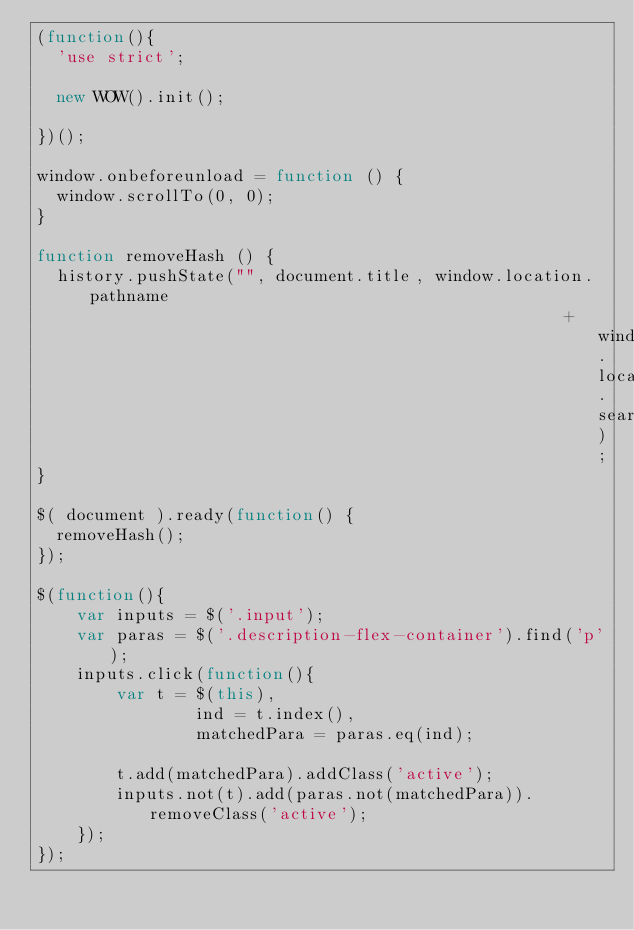<code> <loc_0><loc_0><loc_500><loc_500><_JavaScript_>(function(){
  'use strict';

  new WOW().init();
  
})();

window.onbeforeunload = function () {
  window.scrollTo(0, 0);
}

function removeHash () { 
  history.pushState("", document.title, window.location.pathname
                                                     + window.location.search);
}

$( document ).ready(function() {
  removeHash();
});

$(function(){
	var inputs = $('.input');
	var paras = $('.description-flex-container').find('p');
	inputs.click(function(){
		var t = $(this),
				ind = t.index(),
				matchedPara = paras.eq(ind);
		
		t.add(matchedPara).addClass('active');
		inputs.not(t).add(paras.not(matchedPara)).removeClass('active');
	});
});
</code> 